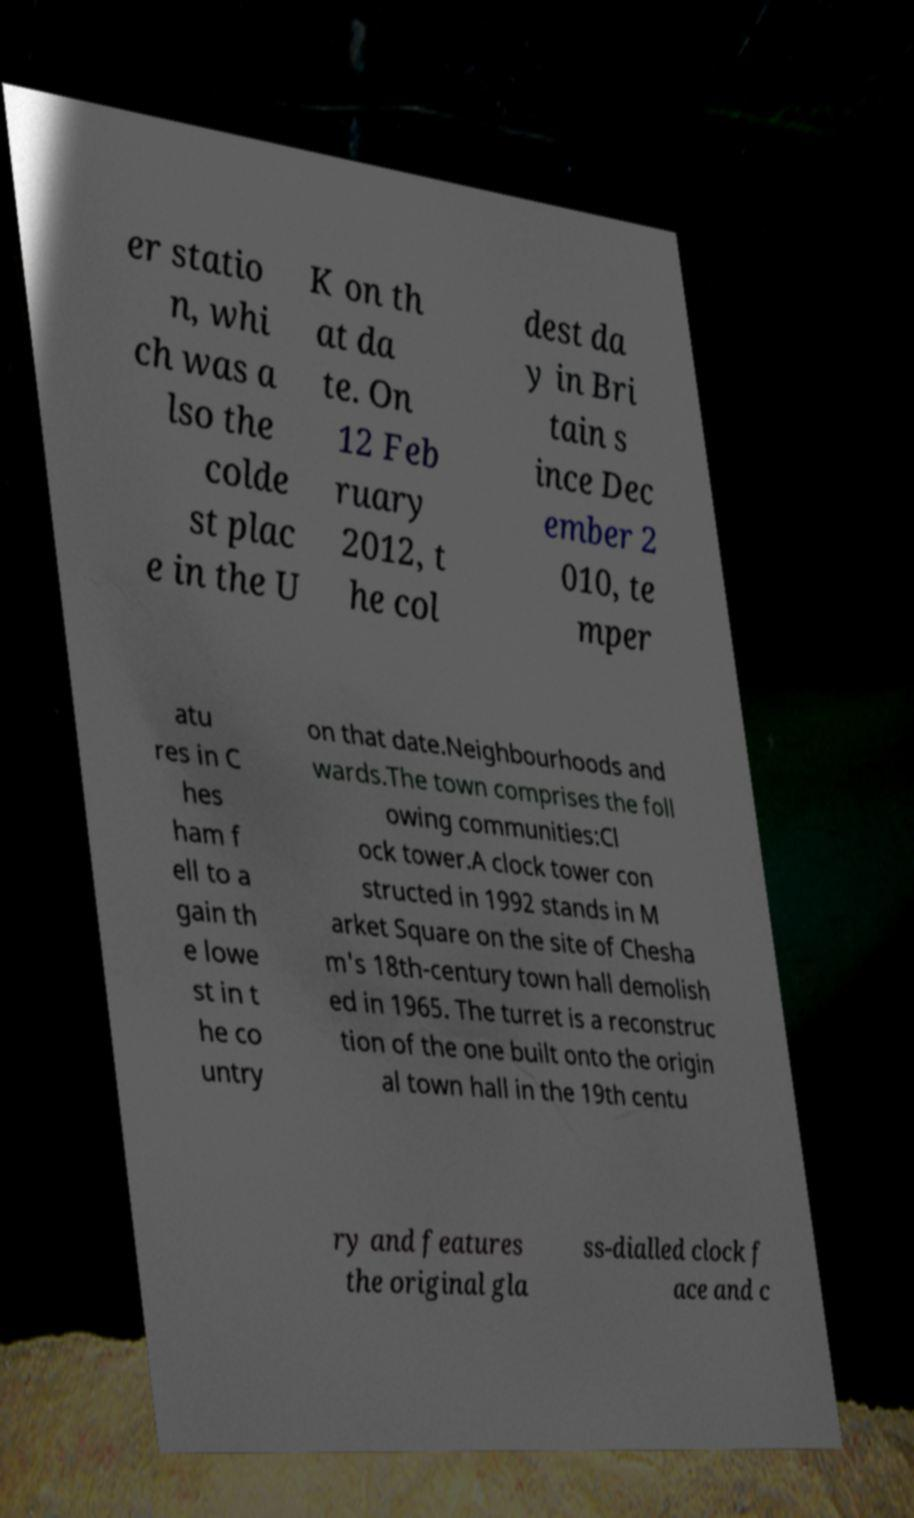Please read and relay the text visible in this image. What does it say? er statio n, whi ch was a lso the colde st plac e in the U K on th at da te. On 12 Feb ruary 2012, t he col dest da y in Bri tain s ince Dec ember 2 010, te mper atu res in C hes ham f ell to a gain th e lowe st in t he co untry on that date.Neighbourhoods and wards.The town comprises the foll owing communities:Cl ock tower.A clock tower con structed in 1992 stands in M arket Square on the site of Chesha m's 18th-century town hall demolish ed in 1965. The turret is a reconstruc tion of the one built onto the origin al town hall in the 19th centu ry and features the original gla ss-dialled clock f ace and c 